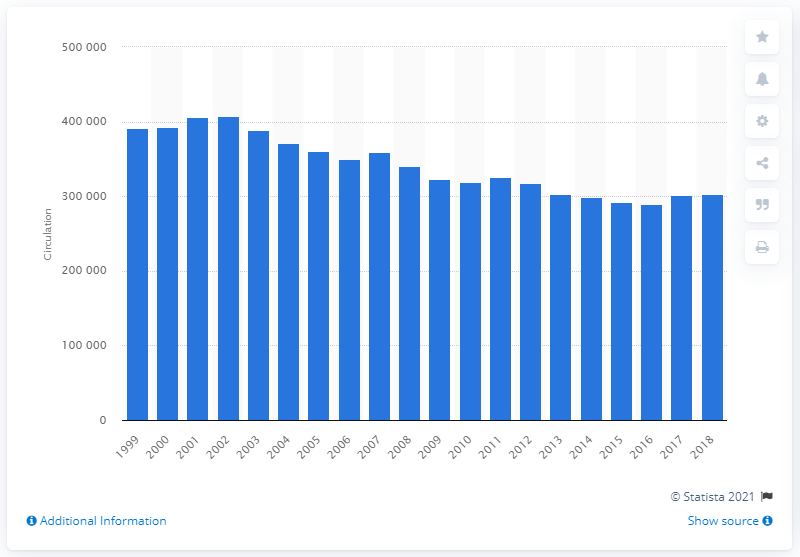Draw attention to some important aspects in this diagram. Le Monde sold a total of 302,240 copies in 2018. 